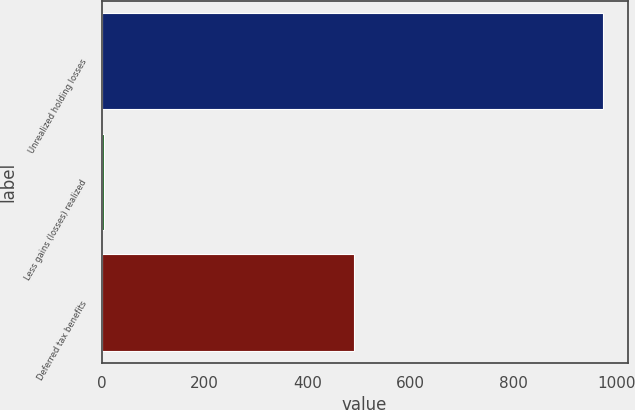Convert chart to OTSL. <chart><loc_0><loc_0><loc_500><loc_500><bar_chart><fcel>Unrealized holding losses<fcel>Less gains (losses) realized<fcel>Deferred tax benefits<nl><fcel>972<fcel>5<fcel>489<nl></chart> 